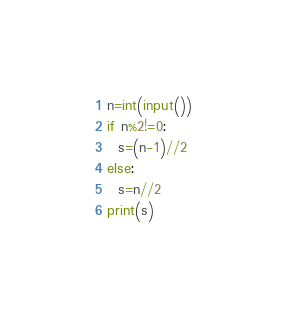Convert code to text. <code><loc_0><loc_0><loc_500><loc_500><_Python_>n=int(input())
if n%2!=0:
  s=(n-1)//2
else:
  s=n//2
print(s)</code> 